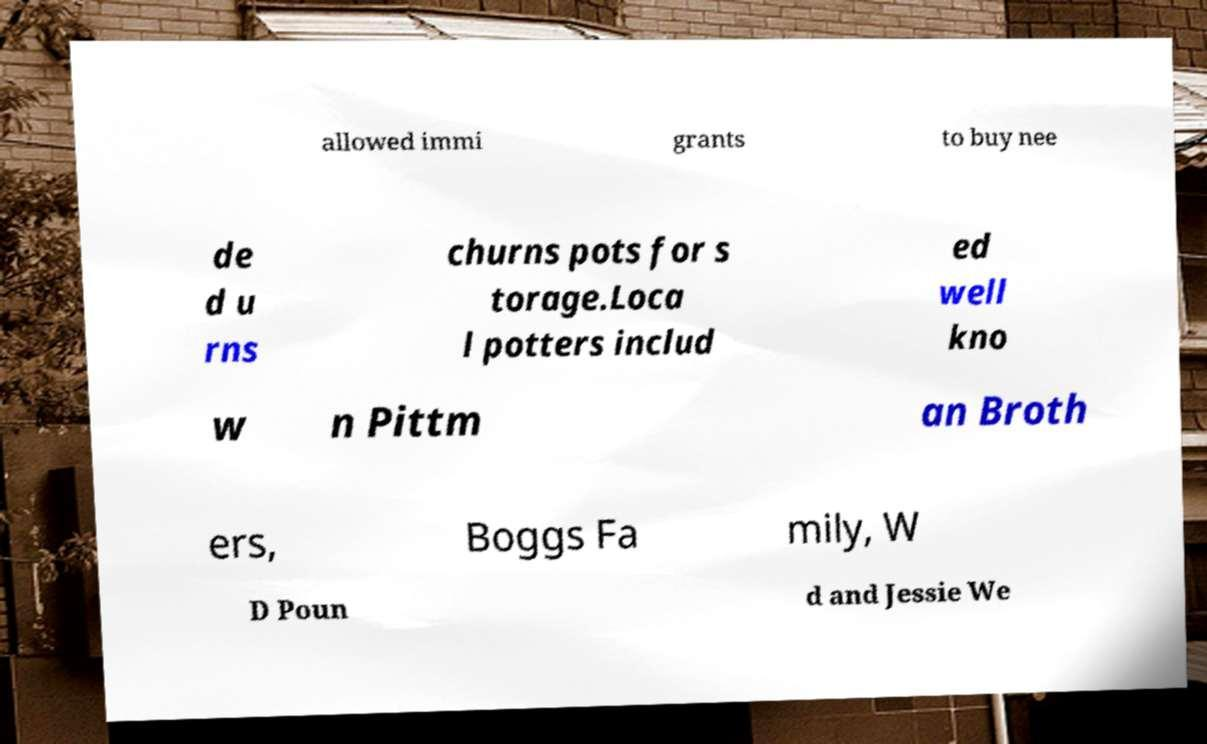Please identify and transcribe the text found in this image. allowed immi grants to buy nee de d u rns churns pots for s torage.Loca l potters includ ed well kno w n Pittm an Broth ers, Boggs Fa mily, W D Poun d and Jessie We 